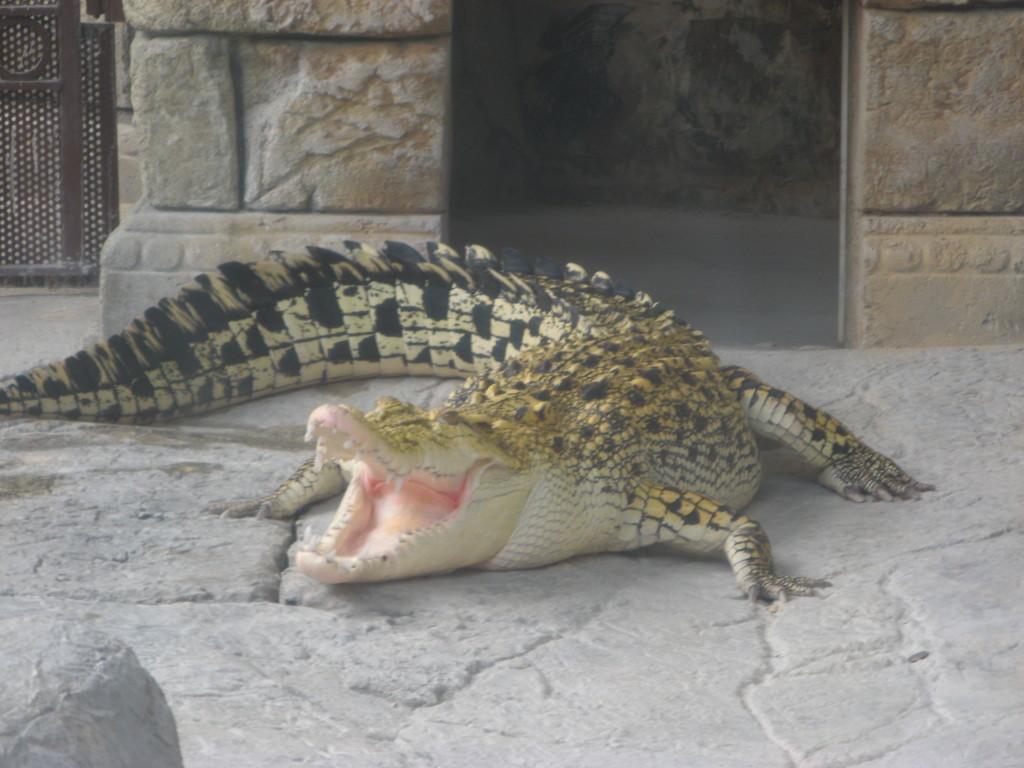Please provide a concise description of this image. In this picture I can observe a crocodile on the land. This crocodile is in black and cream color. In the background I can observe a wall. 